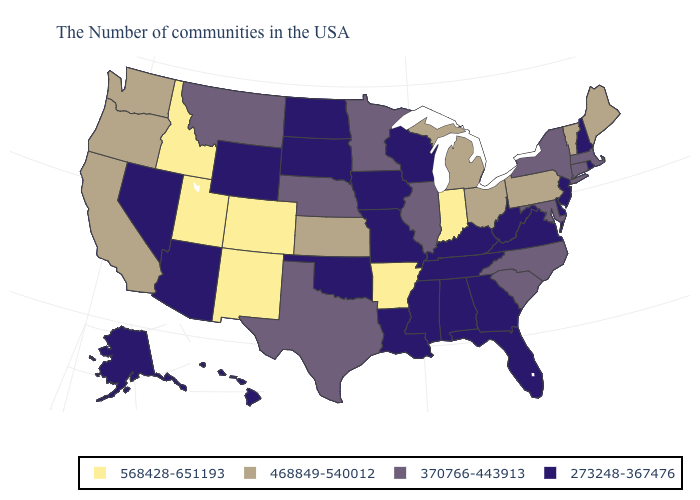Does Nebraska have a higher value than New York?
Keep it brief. No. How many symbols are there in the legend?
Answer briefly. 4. Name the states that have a value in the range 273248-367476?
Short answer required. Rhode Island, New Hampshire, New Jersey, Delaware, Virginia, West Virginia, Florida, Georgia, Kentucky, Alabama, Tennessee, Wisconsin, Mississippi, Louisiana, Missouri, Iowa, Oklahoma, South Dakota, North Dakota, Wyoming, Arizona, Nevada, Alaska, Hawaii. Name the states that have a value in the range 273248-367476?
Quick response, please. Rhode Island, New Hampshire, New Jersey, Delaware, Virginia, West Virginia, Florida, Georgia, Kentucky, Alabama, Tennessee, Wisconsin, Mississippi, Louisiana, Missouri, Iowa, Oklahoma, South Dakota, North Dakota, Wyoming, Arizona, Nevada, Alaska, Hawaii. Name the states that have a value in the range 370766-443913?
Write a very short answer. Massachusetts, Connecticut, New York, Maryland, North Carolina, South Carolina, Illinois, Minnesota, Nebraska, Texas, Montana. What is the value of Texas?
Quick response, please. 370766-443913. Which states have the lowest value in the USA?
Keep it brief. Rhode Island, New Hampshire, New Jersey, Delaware, Virginia, West Virginia, Florida, Georgia, Kentucky, Alabama, Tennessee, Wisconsin, Mississippi, Louisiana, Missouri, Iowa, Oklahoma, South Dakota, North Dakota, Wyoming, Arizona, Nevada, Alaska, Hawaii. What is the highest value in states that border Rhode Island?
Write a very short answer. 370766-443913. Among the states that border Iowa , does South Dakota have the lowest value?
Give a very brief answer. Yes. Among the states that border New Jersey , which have the highest value?
Short answer required. Pennsylvania. Name the states that have a value in the range 273248-367476?
Quick response, please. Rhode Island, New Hampshire, New Jersey, Delaware, Virginia, West Virginia, Florida, Georgia, Kentucky, Alabama, Tennessee, Wisconsin, Mississippi, Louisiana, Missouri, Iowa, Oklahoma, South Dakota, North Dakota, Wyoming, Arizona, Nevada, Alaska, Hawaii. What is the value of Connecticut?
Give a very brief answer. 370766-443913. Does California have the lowest value in the USA?
Be succinct. No. Does Texas have the lowest value in the USA?
Be succinct. No. What is the value of Massachusetts?
Concise answer only. 370766-443913. 